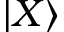<formula> <loc_0><loc_0><loc_500><loc_500>| X \rangle</formula> 